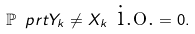Convert formula to latex. <formula><loc_0><loc_0><loc_500><loc_500>\mathbb { P } \ p r t { Y _ { k } \neq X _ { k } \text { i.o.} } = 0 .</formula> 